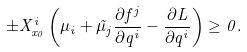<formula> <loc_0><loc_0><loc_500><loc_500>\pm X ^ { i } _ { x _ { 0 } } \left ( \mu _ { i } + \tilde { \mu } _ { j } \frac { \partial f ^ { j } } { \partial q ^ { i } } - \frac { \partial L } { \partial q ^ { i } } \right ) \geq 0 .</formula> 